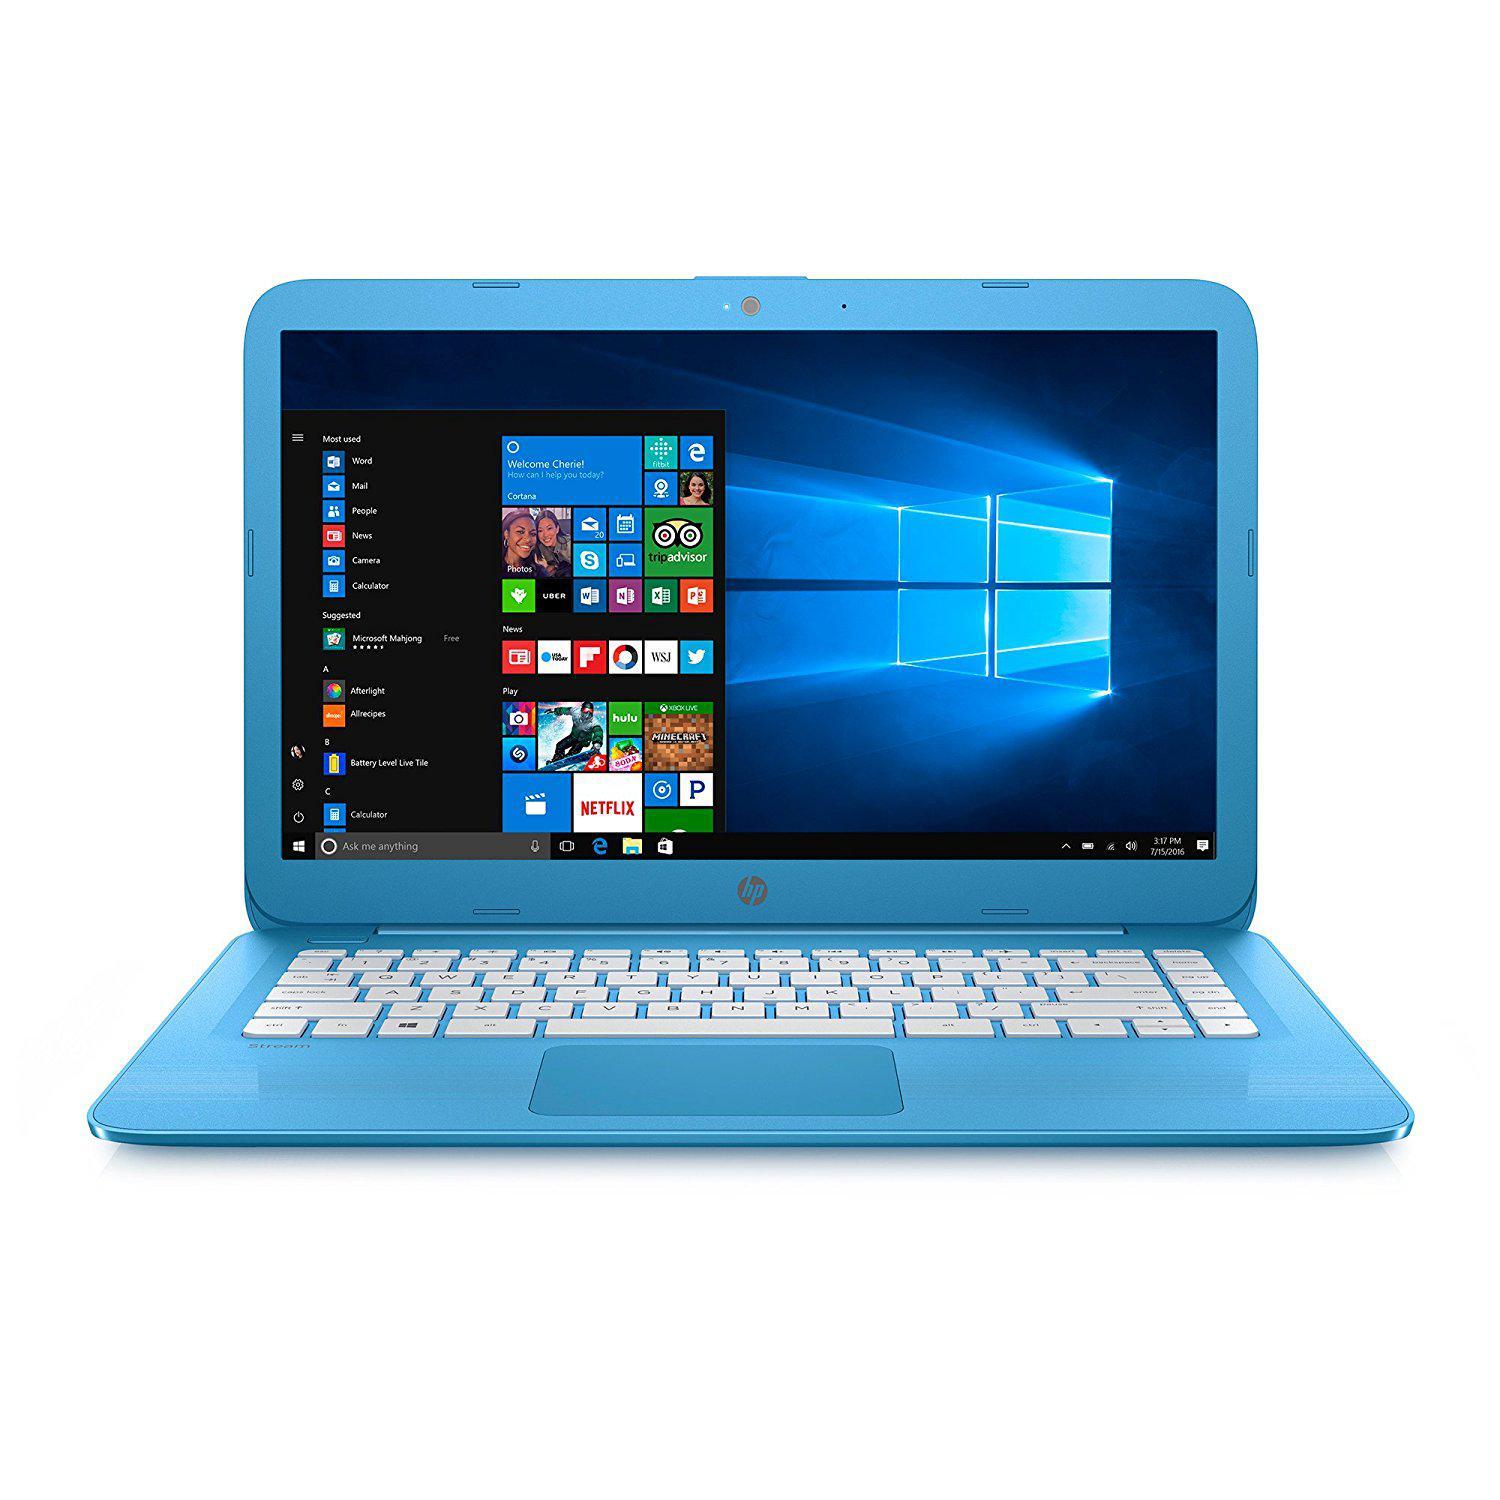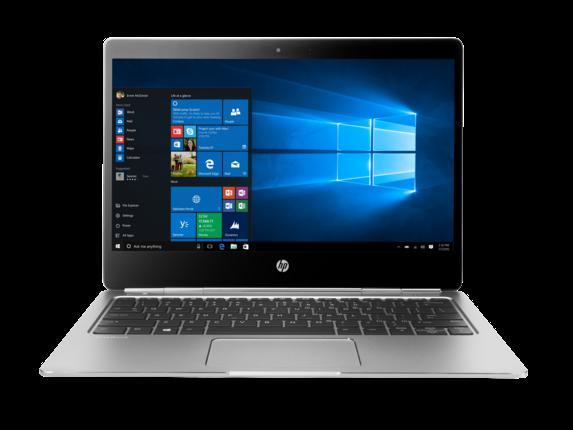The first image is the image on the left, the second image is the image on the right. For the images shown, is this caption "the laptop on the right image has a black background" true? Answer yes or no. Yes. 